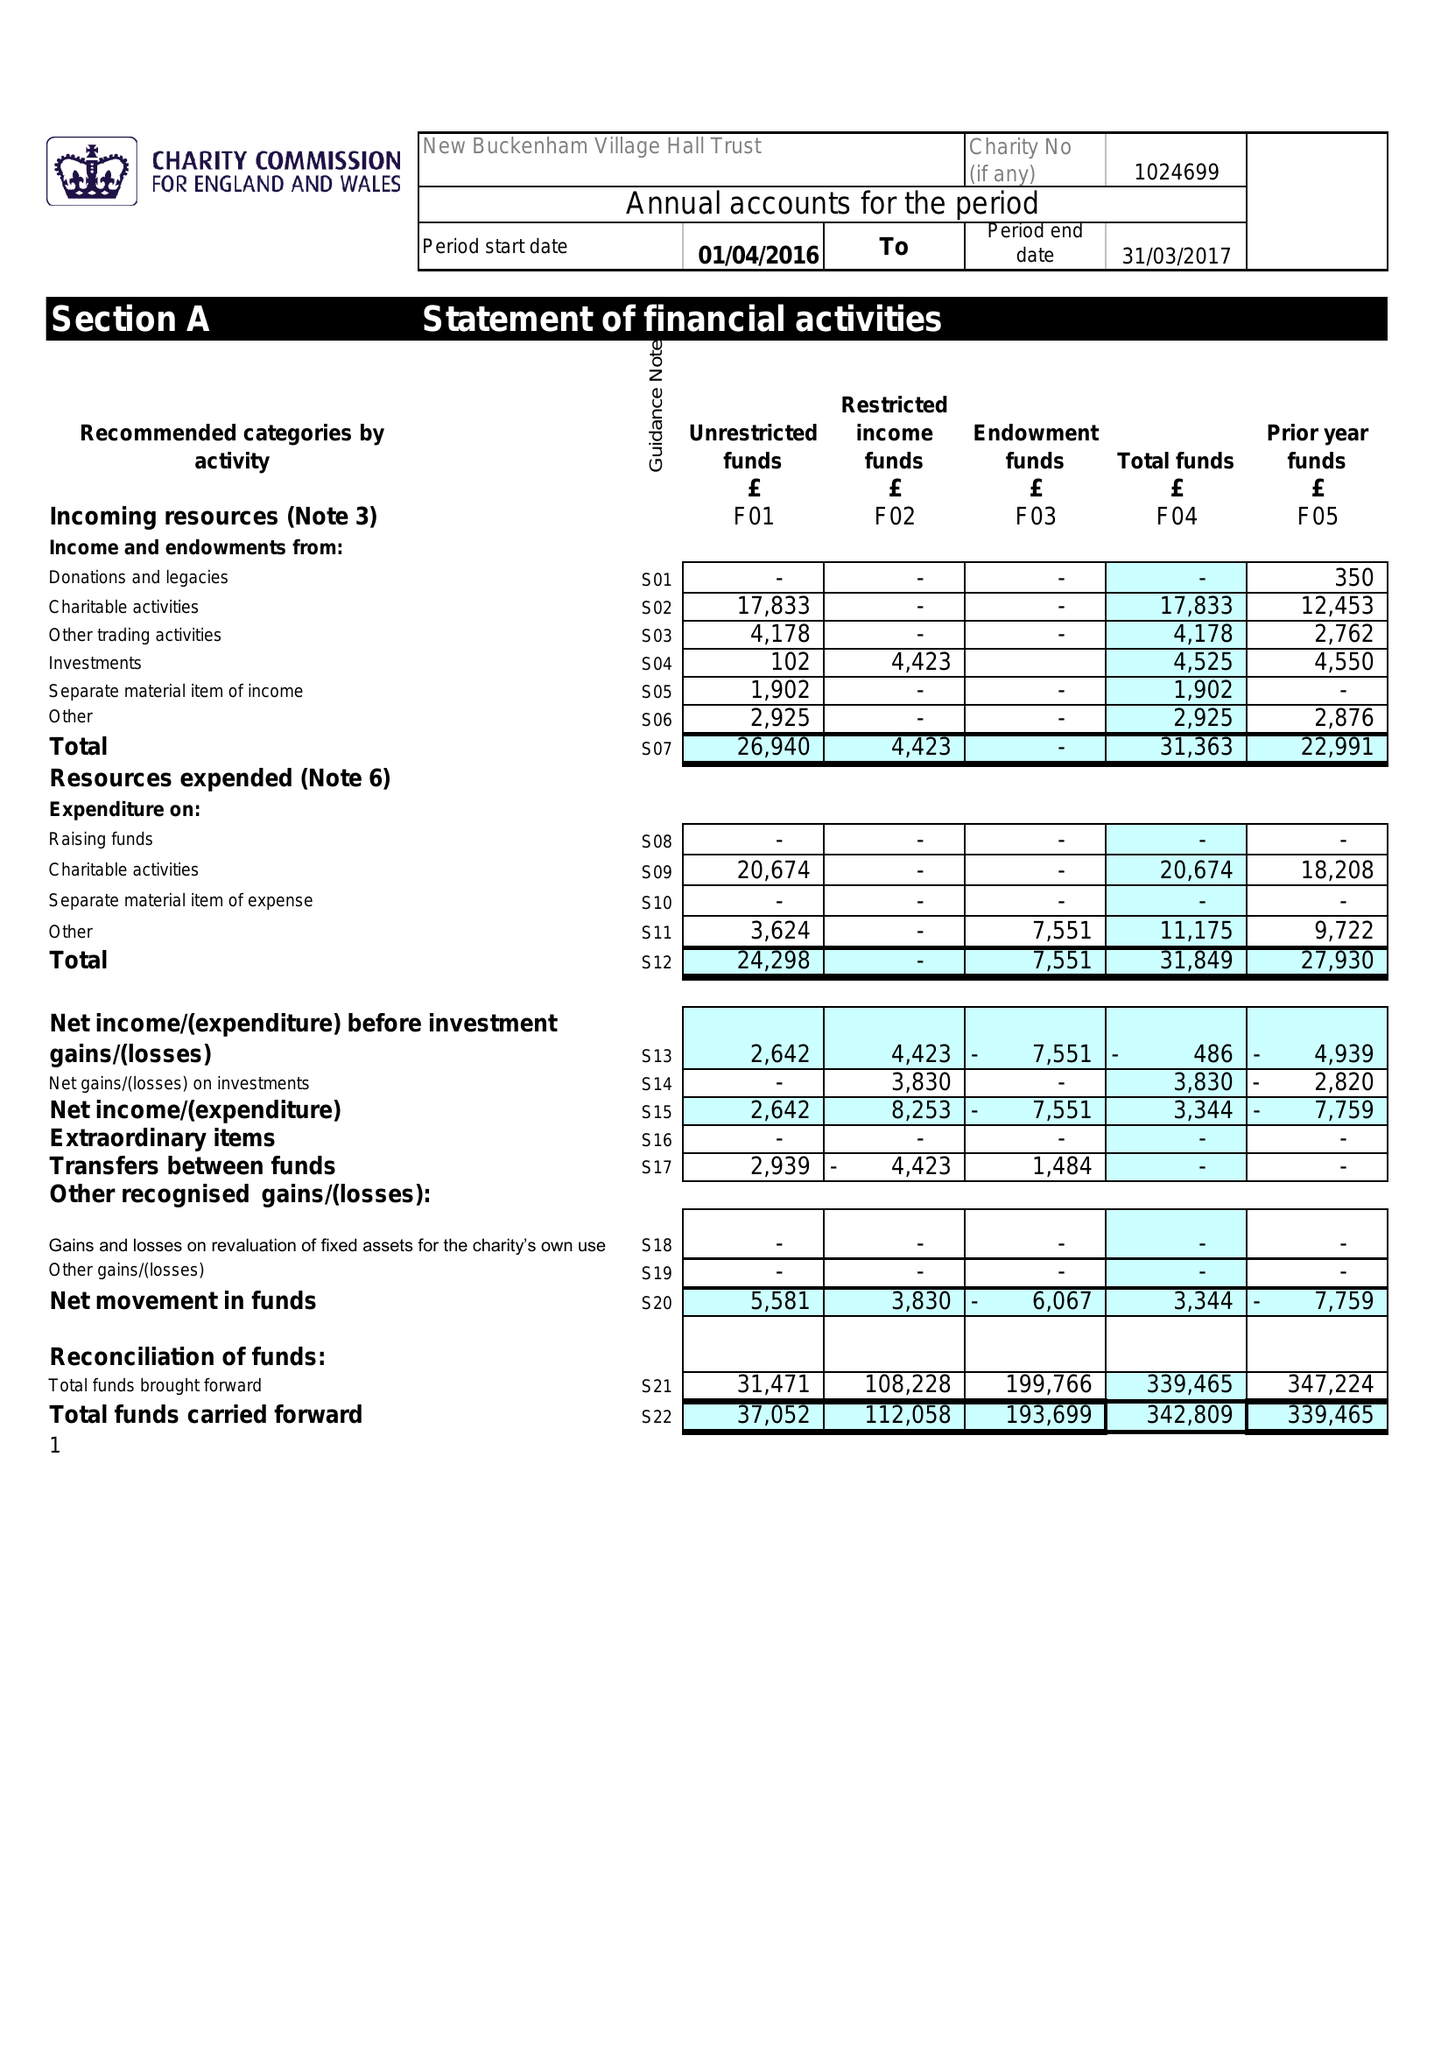What is the value for the address__street_line?
Answer the question using a single word or phrase. MOAT LANE 